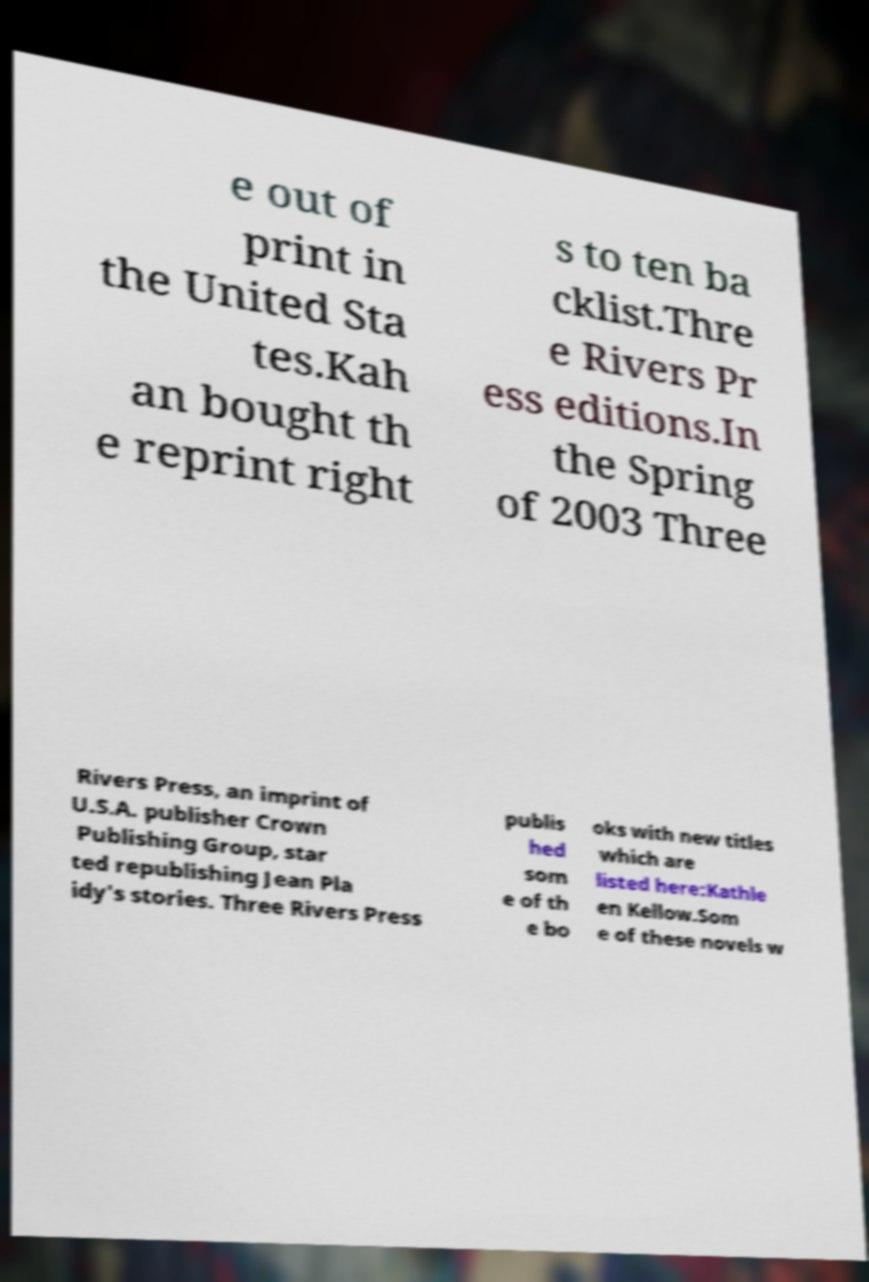Could you assist in decoding the text presented in this image and type it out clearly? e out of print in the United Sta tes.Kah an bought th e reprint right s to ten ba cklist.Thre e Rivers Pr ess editions.In the Spring of 2003 Three Rivers Press, an imprint of U.S.A. publisher Crown Publishing Group, star ted republishing Jean Pla idy's stories. Three Rivers Press publis hed som e of th e bo oks with new titles which are listed here:Kathle en Kellow.Som e of these novels w 